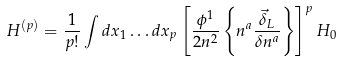Convert formula to latex. <formula><loc_0><loc_0><loc_500><loc_500>H ^ { ( p ) } = \frac { 1 } { p ! } \int d x _ { 1 } \dots d x _ { p } \left [ \frac { \phi ^ { 1 } } { 2 n ^ { 2 } } \left \{ n ^ { a } \frac { \vec { \delta } _ { L } } { \delta n ^ { a } } \right \} \right ] ^ { p } H _ { 0 }</formula> 